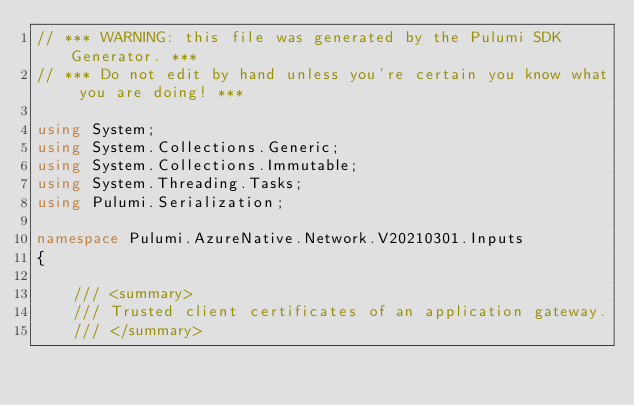Convert code to text. <code><loc_0><loc_0><loc_500><loc_500><_C#_>// *** WARNING: this file was generated by the Pulumi SDK Generator. ***
// *** Do not edit by hand unless you're certain you know what you are doing! ***

using System;
using System.Collections.Generic;
using System.Collections.Immutable;
using System.Threading.Tasks;
using Pulumi.Serialization;

namespace Pulumi.AzureNative.Network.V20210301.Inputs
{

    /// <summary>
    /// Trusted client certificates of an application gateway.
    /// </summary></code> 